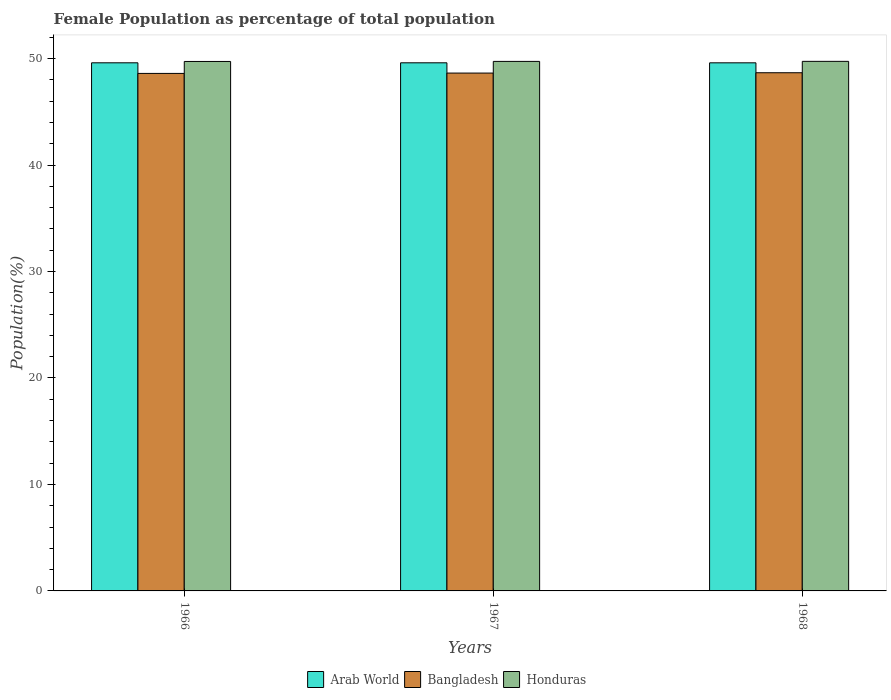How many different coloured bars are there?
Your answer should be compact. 3. How many groups of bars are there?
Provide a short and direct response. 3. Are the number of bars per tick equal to the number of legend labels?
Offer a very short reply. Yes. Are the number of bars on each tick of the X-axis equal?
Provide a short and direct response. Yes. What is the label of the 2nd group of bars from the left?
Your response must be concise. 1967. What is the female population in in Arab World in 1967?
Provide a succinct answer. 49.61. Across all years, what is the maximum female population in in Arab World?
Your response must be concise. 49.61. Across all years, what is the minimum female population in in Honduras?
Your answer should be very brief. 49.73. In which year was the female population in in Arab World maximum?
Make the answer very short. 1966. In which year was the female population in in Arab World minimum?
Provide a succinct answer. 1968. What is the total female population in in Arab World in the graph?
Ensure brevity in your answer.  148.81. What is the difference between the female population in in Arab World in 1966 and that in 1968?
Offer a very short reply. 0. What is the difference between the female population in in Bangladesh in 1968 and the female population in in Honduras in 1967?
Give a very brief answer. -1.06. What is the average female population in in Honduras per year?
Ensure brevity in your answer.  49.74. In the year 1967, what is the difference between the female population in in Bangladesh and female population in in Honduras?
Provide a succinct answer. -1.09. In how many years, is the female population in in Arab World greater than 6 %?
Offer a terse response. 3. What is the ratio of the female population in in Arab World in 1966 to that in 1968?
Your answer should be very brief. 1. Is the difference between the female population in in Bangladesh in 1966 and 1967 greater than the difference between the female population in in Honduras in 1966 and 1967?
Your answer should be very brief. No. What is the difference between the highest and the second highest female population in in Arab World?
Offer a terse response. 0. What is the difference between the highest and the lowest female population in in Bangladesh?
Your answer should be very brief. 0.06. What does the 1st bar from the right in 1967 represents?
Keep it short and to the point. Honduras. Is it the case that in every year, the sum of the female population in in Arab World and female population in in Honduras is greater than the female population in in Bangladesh?
Keep it short and to the point. Yes. How many bars are there?
Offer a very short reply. 9. Are all the bars in the graph horizontal?
Offer a terse response. No. How many years are there in the graph?
Keep it short and to the point. 3. Does the graph contain grids?
Provide a succinct answer. No. What is the title of the graph?
Provide a succinct answer. Female Population as percentage of total population. What is the label or title of the X-axis?
Offer a terse response. Years. What is the label or title of the Y-axis?
Provide a succinct answer. Population(%). What is the Population(%) of Arab World in 1966?
Give a very brief answer. 49.61. What is the Population(%) in Bangladesh in 1966?
Ensure brevity in your answer.  48.61. What is the Population(%) of Honduras in 1966?
Provide a succinct answer. 49.73. What is the Population(%) in Arab World in 1967?
Provide a short and direct response. 49.61. What is the Population(%) in Bangladesh in 1967?
Provide a short and direct response. 48.64. What is the Population(%) in Honduras in 1967?
Your answer should be compact. 49.74. What is the Population(%) in Arab World in 1968?
Keep it short and to the point. 49.6. What is the Population(%) of Bangladesh in 1968?
Your response must be concise. 48.67. What is the Population(%) in Honduras in 1968?
Make the answer very short. 49.74. Across all years, what is the maximum Population(%) in Arab World?
Your response must be concise. 49.61. Across all years, what is the maximum Population(%) of Bangladesh?
Provide a short and direct response. 48.67. Across all years, what is the maximum Population(%) of Honduras?
Provide a short and direct response. 49.74. Across all years, what is the minimum Population(%) of Arab World?
Keep it short and to the point. 49.6. Across all years, what is the minimum Population(%) of Bangladesh?
Offer a very short reply. 48.61. Across all years, what is the minimum Population(%) in Honduras?
Keep it short and to the point. 49.73. What is the total Population(%) in Arab World in the graph?
Offer a terse response. 148.81. What is the total Population(%) of Bangladesh in the graph?
Make the answer very short. 145.92. What is the total Population(%) of Honduras in the graph?
Make the answer very short. 149.21. What is the difference between the Population(%) of Bangladesh in 1966 and that in 1967?
Give a very brief answer. -0.03. What is the difference between the Population(%) of Honduras in 1966 and that in 1967?
Your answer should be compact. -0.01. What is the difference between the Population(%) in Arab World in 1966 and that in 1968?
Your answer should be very brief. 0. What is the difference between the Population(%) of Bangladesh in 1966 and that in 1968?
Your response must be concise. -0.06. What is the difference between the Population(%) of Honduras in 1966 and that in 1968?
Your response must be concise. -0.01. What is the difference between the Population(%) of Arab World in 1967 and that in 1968?
Offer a very short reply. 0. What is the difference between the Population(%) of Bangladesh in 1967 and that in 1968?
Ensure brevity in your answer.  -0.03. What is the difference between the Population(%) of Honduras in 1967 and that in 1968?
Provide a succinct answer. -0. What is the difference between the Population(%) in Arab World in 1966 and the Population(%) in Bangladesh in 1967?
Your answer should be very brief. 0.96. What is the difference between the Population(%) in Arab World in 1966 and the Population(%) in Honduras in 1967?
Offer a terse response. -0.13. What is the difference between the Population(%) in Bangladesh in 1966 and the Population(%) in Honduras in 1967?
Give a very brief answer. -1.13. What is the difference between the Population(%) in Arab World in 1966 and the Population(%) in Bangladesh in 1968?
Give a very brief answer. 0.93. What is the difference between the Population(%) in Arab World in 1966 and the Population(%) in Honduras in 1968?
Keep it short and to the point. -0.14. What is the difference between the Population(%) of Bangladesh in 1966 and the Population(%) of Honduras in 1968?
Make the answer very short. -1.13. What is the difference between the Population(%) in Arab World in 1967 and the Population(%) in Bangladesh in 1968?
Your answer should be very brief. 0.93. What is the difference between the Population(%) in Arab World in 1967 and the Population(%) in Honduras in 1968?
Give a very brief answer. -0.14. What is the difference between the Population(%) in Bangladesh in 1967 and the Population(%) in Honduras in 1968?
Your answer should be compact. -1.1. What is the average Population(%) in Arab World per year?
Give a very brief answer. 49.6. What is the average Population(%) of Bangladesh per year?
Your response must be concise. 48.64. What is the average Population(%) in Honduras per year?
Your response must be concise. 49.74. In the year 1966, what is the difference between the Population(%) of Arab World and Population(%) of Bangladesh?
Provide a succinct answer. 1. In the year 1966, what is the difference between the Population(%) in Arab World and Population(%) in Honduras?
Provide a succinct answer. -0.13. In the year 1966, what is the difference between the Population(%) in Bangladesh and Population(%) in Honduras?
Your answer should be very brief. -1.12. In the year 1967, what is the difference between the Population(%) of Arab World and Population(%) of Bangladesh?
Your response must be concise. 0.96. In the year 1967, what is the difference between the Population(%) in Arab World and Population(%) in Honduras?
Your response must be concise. -0.13. In the year 1967, what is the difference between the Population(%) of Bangladesh and Population(%) of Honduras?
Provide a short and direct response. -1.09. In the year 1968, what is the difference between the Population(%) of Arab World and Population(%) of Bangladesh?
Provide a succinct answer. 0.93. In the year 1968, what is the difference between the Population(%) in Arab World and Population(%) in Honduras?
Your answer should be very brief. -0.14. In the year 1968, what is the difference between the Population(%) in Bangladesh and Population(%) in Honduras?
Your answer should be very brief. -1.07. What is the ratio of the Population(%) in Arab World in 1966 to that in 1967?
Your answer should be compact. 1. What is the ratio of the Population(%) of Bangladesh in 1966 to that in 1967?
Offer a very short reply. 1. What is the ratio of the Population(%) of Arab World in 1966 to that in 1968?
Provide a short and direct response. 1. What is the difference between the highest and the second highest Population(%) in Arab World?
Offer a terse response. 0. What is the difference between the highest and the second highest Population(%) in Bangladesh?
Offer a very short reply. 0.03. What is the difference between the highest and the second highest Population(%) of Honduras?
Your response must be concise. 0. What is the difference between the highest and the lowest Population(%) of Arab World?
Provide a succinct answer. 0. What is the difference between the highest and the lowest Population(%) in Bangladesh?
Provide a succinct answer. 0.06. What is the difference between the highest and the lowest Population(%) of Honduras?
Make the answer very short. 0.01. 